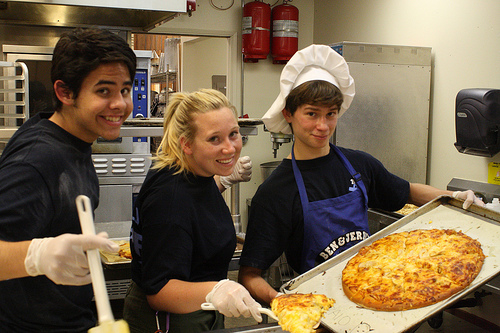What kind of environment are they in? They are in a kitchen environment, as indicated by the professional kitchen equipment, stainless steel surfaces, and the chef's hat worn by one person, pointing towards a restaurant or culinary school setting. 